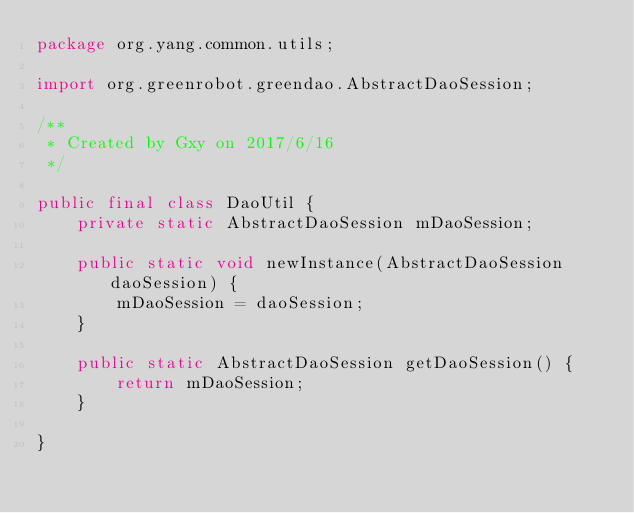<code> <loc_0><loc_0><loc_500><loc_500><_Java_>package org.yang.common.utils;

import org.greenrobot.greendao.AbstractDaoSession;

/**
 * Created by Gxy on 2017/6/16
 */

public final class DaoUtil {
    private static AbstractDaoSession mDaoSession;

    public static void newInstance(AbstractDaoSession daoSession) {
        mDaoSession = daoSession;
    }

    public static AbstractDaoSession getDaoSession() {
        return mDaoSession;
    }

}
</code> 